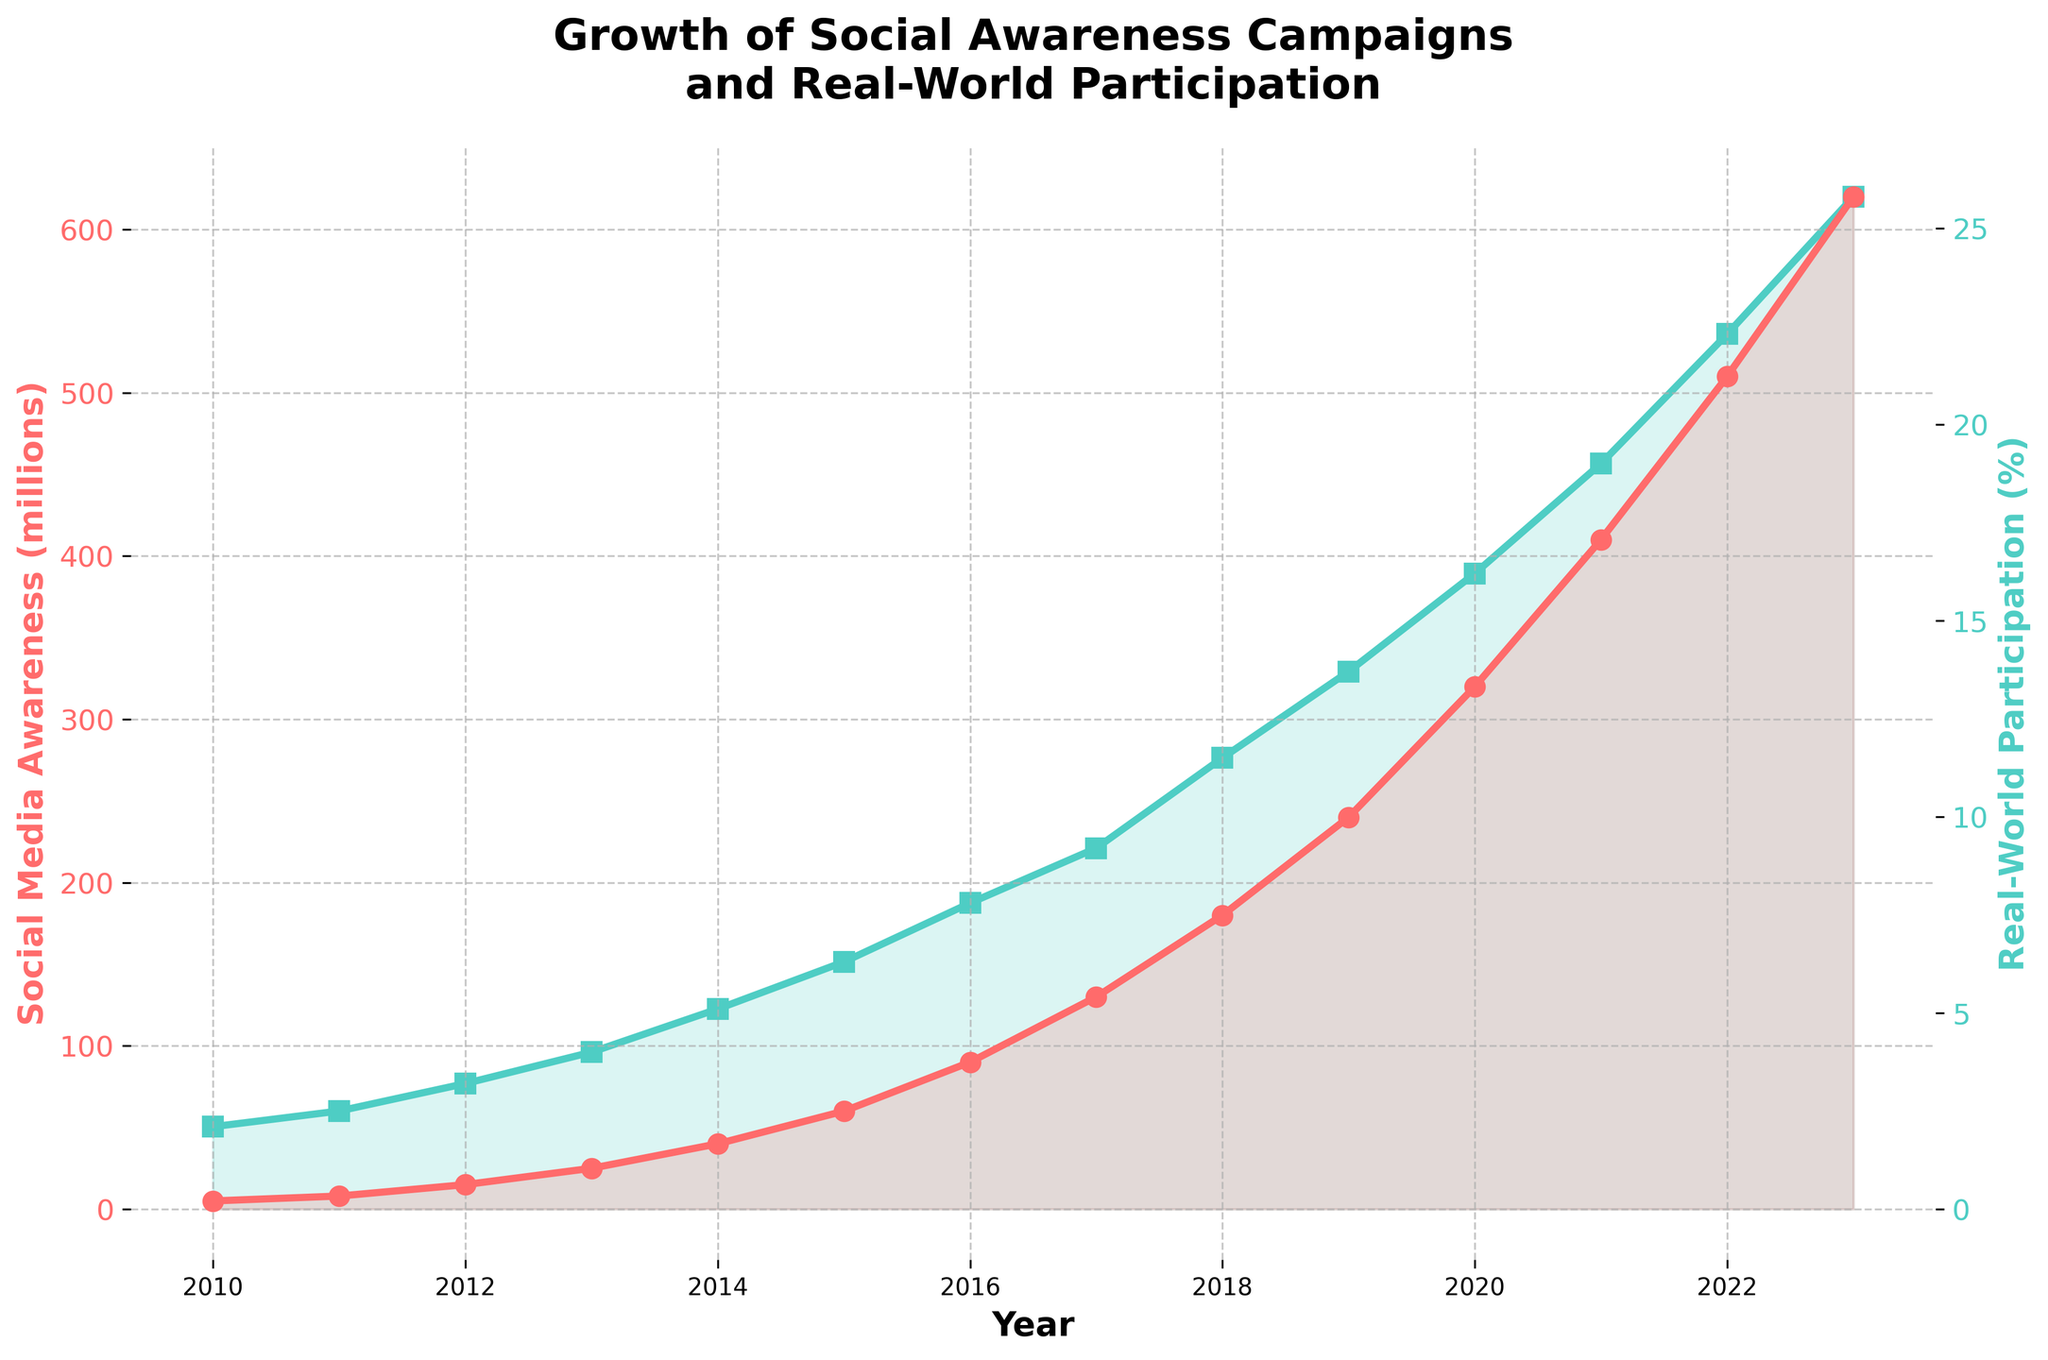What is the difference between the Social Media Awareness values in 2020 and 2023? To find the difference, subtract the value in 2020 (320 million) from the value in 2023 (620 million): 620 - 320 = 300 million.
Answer: 300 million Which year shows the biggest jump in Real-World Participation percentage from the previous year? To determine the biggest jump, compare the year-over-year differences in Real-World Participation: 2023 (25.8%) - 2022 (22.3%) = 3.5%, which is the highest.
Answer: 2023 What is the average Real-World Participation percentage over the years 2015 to 2020? Calculate the sum of the percentages from 2015 to 2020: (6.3% + 7.8% + 9.2% + 11.5% + 13.7% + 16.2%) = 64.7%, then divide by the number of years (6): 64.7 / 6 ≈ 10.78%.
Answer: 10.78% Between which two consecutive years did Social Media Awareness cross the 100-million mark? Identify when Social Media Awareness first exceeds 100 million: between 2016 (90 million) and 2017 (130 million).
Answer: 2016 and 2017 Is the trend of Social Media Awareness and Real-World Participation both increasing over the years? Observe both plotted lines for Social Media Awareness and Real-World Participation: both show a consistently upward trend from 2010 to 2023.
Answer: Yes Which visual line color represents Real-World Participation percentage? Identify the line by its color: Real-World Participation is represented by the green line.
Answer: Green What is the Real-World Participation percentage in 2019 compared to the previous year, 2018? Calculate the percentage increase from 2018 (11.5%) to 2019 (13.7%): 13.7% - 11.5% = 2.2%.
Answer: 2.2% By how many millions did Social Media Awareness increase from 2012 to 2015? Find the difference in Social Media Awareness between 2012 (15 million) and 2015 (60 million): 60 - 15 = 45 million.
Answer: 45 million Between 2010 and 2023, what is the cumulative increase in Real-World Participation percentage? Calculate the difference in Real-World Participation from 2010 (2.1%) to 2023 (25.8%): 25.8% - 2.1% = 23.7%.
Answer: 23.7% At what years are the 'Influencer Impact' annotated in the plot, and how is it visually indicated? The 'Influencer Impact' annotation is indicated in 2020, with an arrow pointing from 2018 to 2020.
Answer: 2020, arrow from 2018 